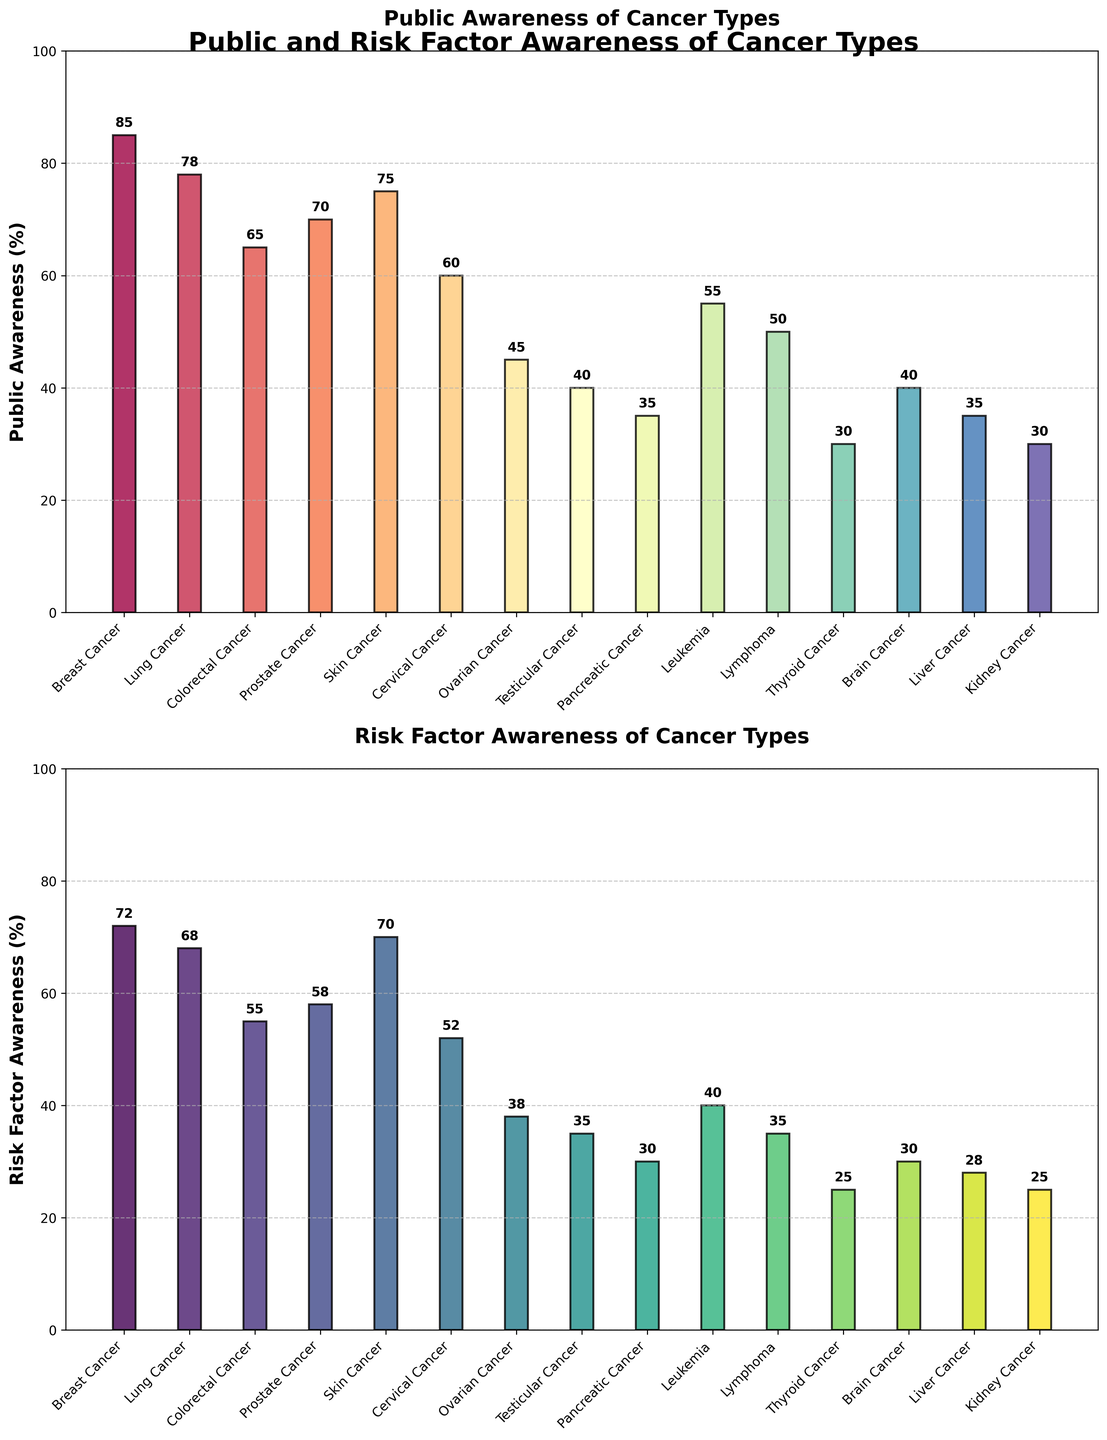What are the titles of the two subplots? The titles can be found at the top of each subplot. The first subplot's title is "Public Awareness of Cancer Types," and the second subplot's title is "Risk Factor Awareness of Cancer Types."
Answer: "Public Awareness of Cancer Types" and "Risk Factor Awareness of Cancer Types" What is the public awareness percentage for Breast Cancer? Locate the bar representing Breast Cancer in the first subplot and read the value annotated above it. The public awareness percentage for Breast Cancer is indicated as 85%.
Answer: 85% Which cancer type has the lowest public awareness? Examine the first subplot to find the bar with the shortest height. The smallest bar represents Thyroid Cancer, which has a public awareness percentage of 30%.
Answer: Thyroid Cancer Is the public awareness of Lung Cancer greater than or less than that of Prostate Cancer? Compare the heights of the bars for Lung Cancer and Prostate Cancer in the first subplot. The bar for Lung Cancer (78%) is taller than the bar for Prostate Cancer (70%).
Answer: Greater than What is the difference in risk factor awareness between Skin Cancer and Liver Cancer? Locate the bars for Skin Cancer and Liver Cancer in the second subplot. Skin Cancer has a risk factor awareness of 70%, and Liver Cancer has 28%. Compute the difference: 70% - 28% = 42%.
Answer: 42% Which cancer type shows the highest awareness discrepancy between public and risk factor awareness? Identify the difference between the bars in each pair (public vs. risk factor awareness) for all cancer types. Breast Cancer has a public awareness of 85% and risk factor awareness of 72%, a discrepancy of 13 percentage points. Other calculated differences reveal Prostate Cancer with a difference of 12 points. Breast Cancer has the highest discrepancy of 13%.
Answer: Breast Cancer How many cancer types have a risk factor awareness percentage greater than 50%? Count the bars in the second subplot with heights exceeding the 50% mark. These cancer types are: Breast Cancer (72%), Lung Cancer (68%), Colorectal Cancer (55%), Prostate Cancer (58%), and Skin Cancer (70%). That makes a total of 5 cancer types.
Answer: 5 What is the average public awareness percentage for all cancer types combined? Sum all the public awareness percentages and divide by the number of cancer types. (85 + 78 + 65 + 70 + 75 + 60 + 45 + 40 + 35 + 55 + 50 + 30 + 40 + 35 + 30) / 15 = 55.33%.
Answer: 55.33% Which cancer type has the smallest gap between public awareness and risk factor awareness? Calculate the gap for each cancer type by taking the absolute value of the differences between the public and risk factor awareness. Liver Cancer (35-28=7) and Kidney Cancer (30-25=5) show the smallest gaps. Kidney Cancer with a difference of 5.
Answer: Kidney Cancer Is the risk factor awareness for Prostate Cancer greater than Testicular Cancer? Compare the heights of the bars representing Prostate Cancer and Testicular Cancer in the second subplot. Prostate Cancer has a risk factor awareness of 58%, whereas Testicular Cancer has 35%. Prostate Cancer's risk factor awareness is greater.
Answer: Yes 